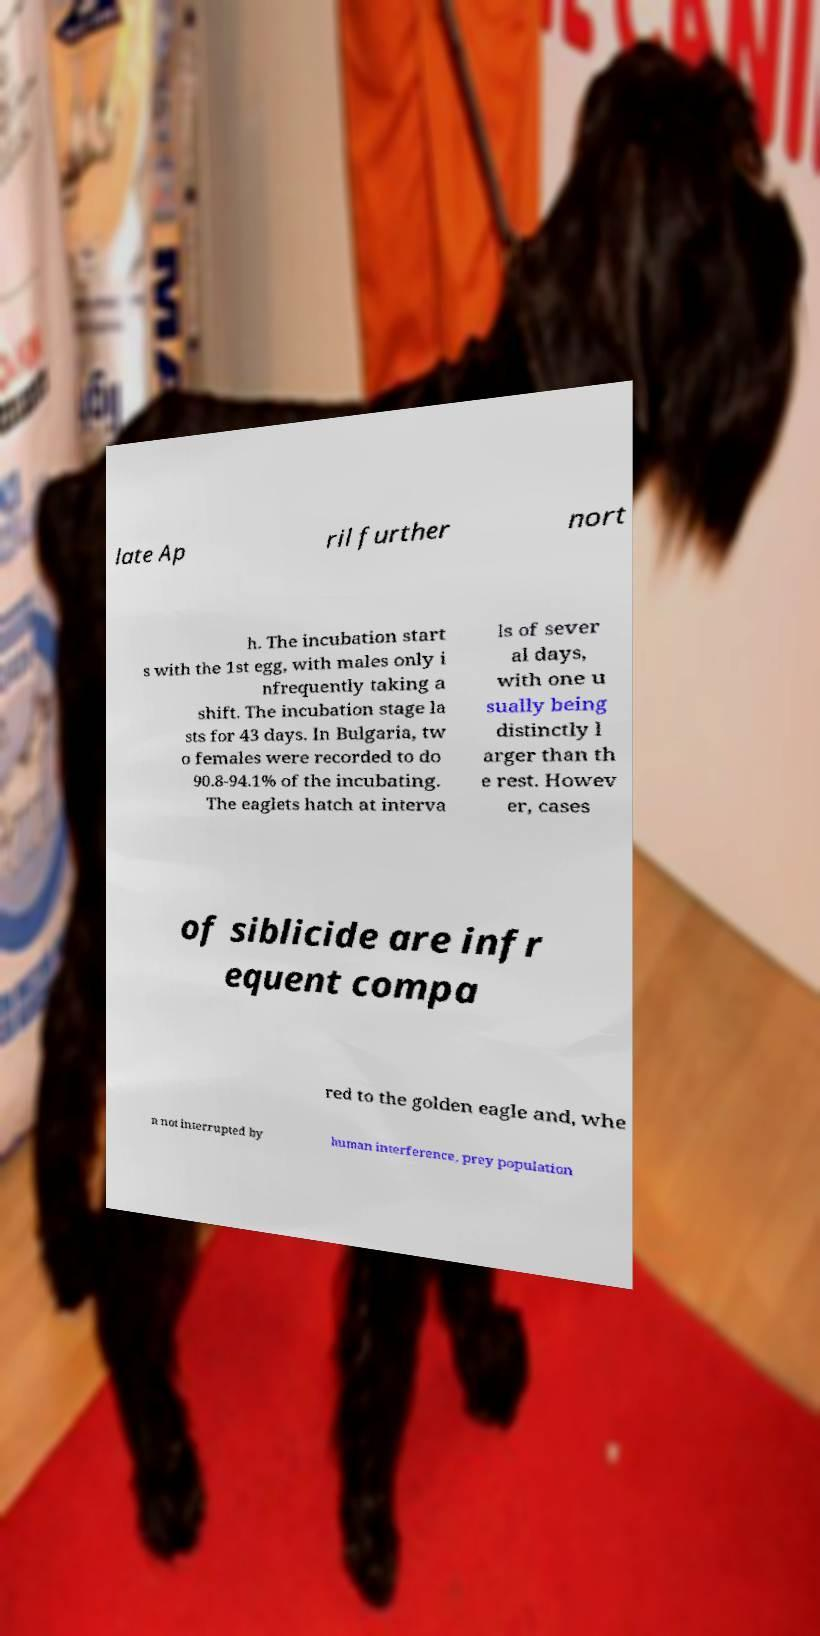There's text embedded in this image that I need extracted. Can you transcribe it verbatim? late Ap ril further nort h. The incubation start s with the 1st egg, with males only i nfrequently taking a shift. The incubation stage la sts for 43 days. In Bulgaria, tw o females were recorded to do 90.8-94.1% of the incubating. The eaglets hatch at interva ls of sever al days, with one u sually being distinctly l arger than th e rest. Howev er, cases of siblicide are infr equent compa red to the golden eagle and, whe n not interrupted by human interference, prey population 